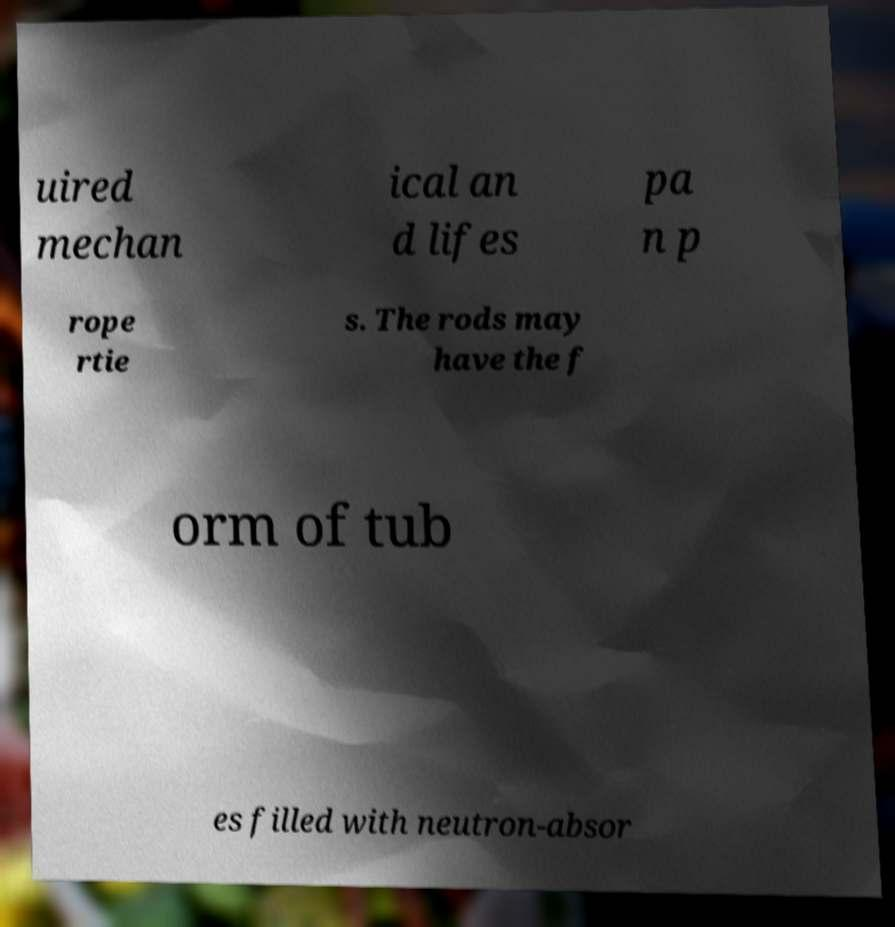Please read and relay the text visible in this image. What does it say? uired mechan ical an d lifes pa n p rope rtie s. The rods may have the f orm of tub es filled with neutron-absor 